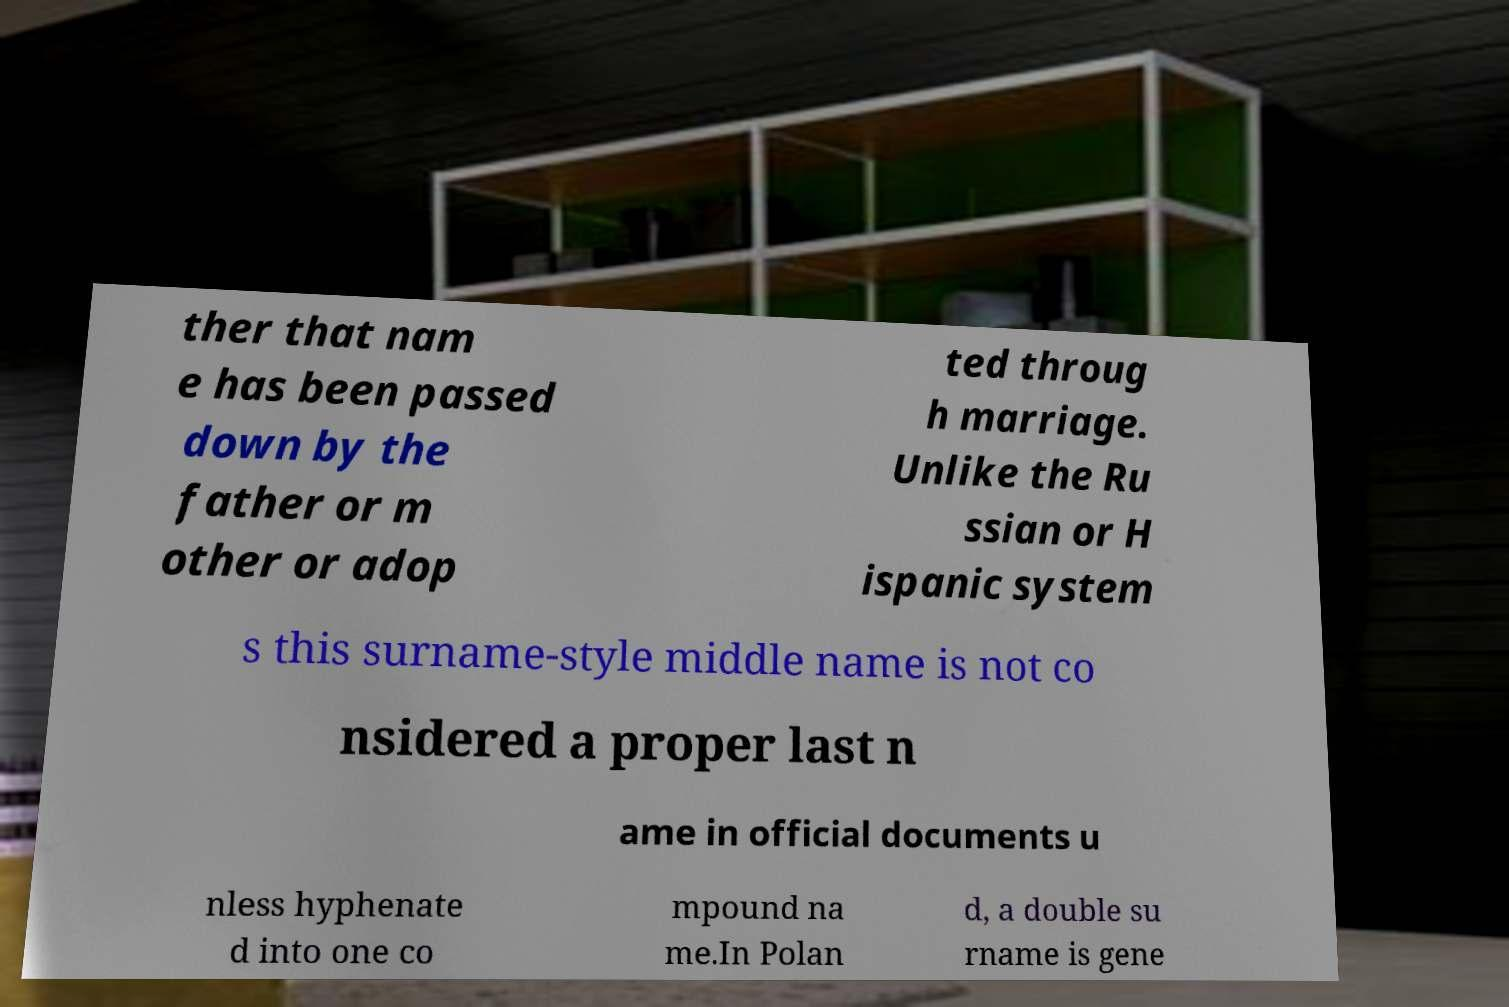For documentation purposes, I need the text within this image transcribed. Could you provide that? ther that nam e has been passed down by the father or m other or adop ted throug h marriage. Unlike the Ru ssian or H ispanic system s this surname-style middle name is not co nsidered a proper last n ame in official documents u nless hyphenate d into one co mpound na me.In Polan d, a double su rname is gene 